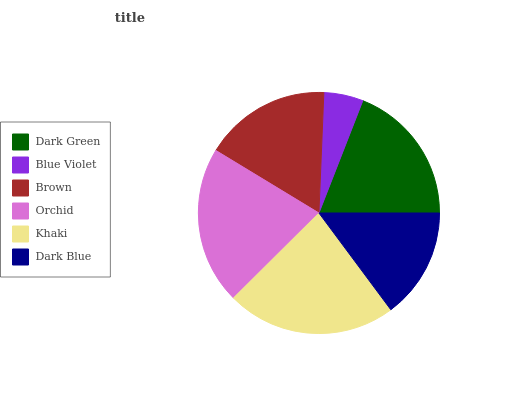Is Blue Violet the minimum?
Answer yes or no. Yes. Is Khaki the maximum?
Answer yes or no. Yes. Is Brown the minimum?
Answer yes or no. No. Is Brown the maximum?
Answer yes or no. No. Is Brown greater than Blue Violet?
Answer yes or no. Yes. Is Blue Violet less than Brown?
Answer yes or no. Yes. Is Blue Violet greater than Brown?
Answer yes or no. No. Is Brown less than Blue Violet?
Answer yes or no. No. Is Dark Green the high median?
Answer yes or no. Yes. Is Brown the low median?
Answer yes or no. Yes. Is Brown the high median?
Answer yes or no. No. Is Dark Blue the low median?
Answer yes or no. No. 